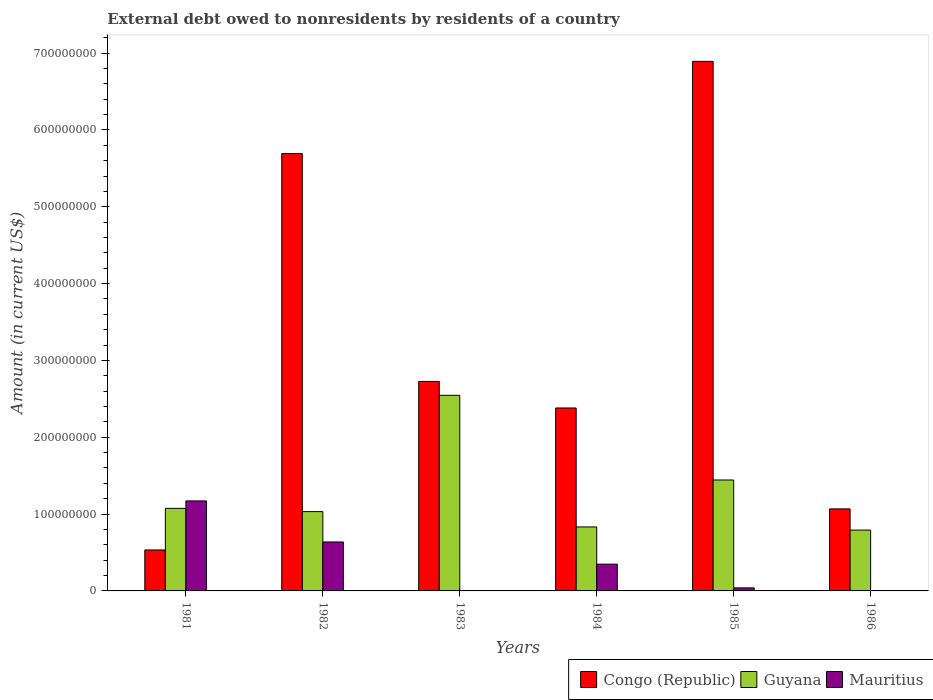How many different coloured bars are there?
Your answer should be compact. 3. How many bars are there on the 1st tick from the right?
Your answer should be very brief. 2. What is the label of the 1st group of bars from the left?
Your answer should be compact. 1981. In how many cases, is the number of bars for a given year not equal to the number of legend labels?
Provide a short and direct response. 2. Across all years, what is the maximum external debt owed by residents in Mauritius?
Your answer should be very brief. 1.17e+08. Across all years, what is the minimum external debt owed by residents in Congo (Republic)?
Your response must be concise. 5.33e+07. What is the total external debt owed by residents in Mauritius in the graph?
Your response must be concise. 2.20e+08. What is the difference between the external debt owed by residents in Congo (Republic) in 1982 and that in 1983?
Offer a very short reply. 2.97e+08. What is the difference between the external debt owed by residents in Mauritius in 1986 and the external debt owed by residents in Guyana in 1983?
Make the answer very short. -2.55e+08. What is the average external debt owed by residents in Guyana per year?
Give a very brief answer. 1.29e+08. In the year 1981, what is the difference between the external debt owed by residents in Congo (Republic) and external debt owed by residents in Mauritius?
Offer a terse response. -6.38e+07. In how many years, is the external debt owed by residents in Congo (Republic) greater than 40000000 US$?
Keep it short and to the point. 6. What is the ratio of the external debt owed by residents in Congo (Republic) in 1985 to that in 1986?
Keep it short and to the point. 6.46. Is the external debt owed by residents in Congo (Republic) in 1983 less than that in 1984?
Your answer should be compact. No. What is the difference between the highest and the second highest external debt owed by residents in Guyana?
Your answer should be compact. 1.10e+08. What is the difference between the highest and the lowest external debt owed by residents in Guyana?
Provide a short and direct response. 1.75e+08. In how many years, is the external debt owed by residents in Guyana greater than the average external debt owed by residents in Guyana taken over all years?
Provide a succinct answer. 2. Are all the bars in the graph horizontal?
Give a very brief answer. No. How many years are there in the graph?
Provide a short and direct response. 6. What is the difference between two consecutive major ticks on the Y-axis?
Provide a short and direct response. 1.00e+08. Does the graph contain grids?
Ensure brevity in your answer.  No. Where does the legend appear in the graph?
Make the answer very short. Bottom right. How many legend labels are there?
Your answer should be very brief. 3. How are the legend labels stacked?
Your response must be concise. Horizontal. What is the title of the graph?
Provide a short and direct response. External debt owed to nonresidents by residents of a country. What is the label or title of the X-axis?
Give a very brief answer. Years. What is the label or title of the Y-axis?
Your response must be concise. Amount (in current US$). What is the Amount (in current US$) of Congo (Republic) in 1981?
Your answer should be compact. 5.33e+07. What is the Amount (in current US$) in Guyana in 1981?
Keep it short and to the point. 1.07e+08. What is the Amount (in current US$) of Mauritius in 1981?
Give a very brief answer. 1.17e+08. What is the Amount (in current US$) of Congo (Republic) in 1982?
Ensure brevity in your answer.  5.69e+08. What is the Amount (in current US$) in Guyana in 1982?
Your answer should be compact. 1.03e+08. What is the Amount (in current US$) in Mauritius in 1982?
Provide a succinct answer. 6.37e+07. What is the Amount (in current US$) in Congo (Republic) in 1983?
Make the answer very short. 2.73e+08. What is the Amount (in current US$) of Guyana in 1983?
Offer a terse response. 2.55e+08. What is the Amount (in current US$) in Congo (Republic) in 1984?
Provide a succinct answer. 2.38e+08. What is the Amount (in current US$) of Guyana in 1984?
Give a very brief answer. 8.33e+07. What is the Amount (in current US$) in Mauritius in 1984?
Your answer should be compact. 3.48e+07. What is the Amount (in current US$) in Congo (Republic) in 1985?
Keep it short and to the point. 6.89e+08. What is the Amount (in current US$) of Guyana in 1985?
Offer a terse response. 1.44e+08. What is the Amount (in current US$) of Mauritius in 1985?
Keep it short and to the point. 3.95e+06. What is the Amount (in current US$) of Congo (Republic) in 1986?
Offer a terse response. 1.07e+08. What is the Amount (in current US$) in Guyana in 1986?
Provide a short and direct response. 7.92e+07. Across all years, what is the maximum Amount (in current US$) in Congo (Republic)?
Your answer should be very brief. 6.89e+08. Across all years, what is the maximum Amount (in current US$) of Guyana?
Provide a short and direct response. 2.55e+08. Across all years, what is the maximum Amount (in current US$) of Mauritius?
Make the answer very short. 1.17e+08. Across all years, what is the minimum Amount (in current US$) in Congo (Republic)?
Make the answer very short. 5.33e+07. Across all years, what is the minimum Amount (in current US$) of Guyana?
Make the answer very short. 7.92e+07. Across all years, what is the minimum Amount (in current US$) of Mauritius?
Give a very brief answer. 0. What is the total Amount (in current US$) of Congo (Republic) in the graph?
Ensure brevity in your answer.  1.93e+09. What is the total Amount (in current US$) in Guyana in the graph?
Keep it short and to the point. 7.72e+08. What is the total Amount (in current US$) of Mauritius in the graph?
Offer a very short reply. 2.20e+08. What is the difference between the Amount (in current US$) of Congo (Republic) in 1981 and that in 1982?
Your answer should be compact. -5.16e+08. What is the difference between the Amount (in current US$) in Guyana in 1981 and that in 1982?
Provide a short and direct response. 4.26e+06. What is the difference between the Amount (in current US$) in Mauritius in 1981 and that in 1982?
Make the answer very short. 5.34e+07. What is the difference between the Amount (in current US$) in Congo (Republic) in 1981 and that in 1983?
Your answer should be compact. -2.19e+08. What is the difference between the Amount (in current US$) of Guyana in 1981 and that in 1983?
Ensure brevity in your answer.  -1.47e+08. What is the difference between the Amount (in current US$) in Congo (Republic) in 1981 and that in 1984?
Your answer should be very brief. -1.85e+08. What is the difference between the Amount (in current US$) in Guyana in 1981 and that in 1984?
Provide a succinct answer. 2.42e+07. What is the difference between the Amount (in current US$) of Mauritius in 1981 and that in 1984?
Provide a short and direct response. 8.23e+07. What is the difference between the Amount (in current US$) of Congo (Republic) in 1981 and that in 1985?
Ensure brevity in your answer.  -6.36e+08. What is the difference between the Amount (in current US$) of Guyana in 1981 and that in 1985?
Your answer should be compact. -3.69e+07. What is the difference between the Amount (in current US$) of Mauritius in 1981 and that in 1985?
Your answer should be compact. 1.13e+08. What is the difference between the Amount (in current US$) in Congo (Republic) in 1981 and that in 1986?
Ensure brevity in your answer.  -5.35e+07. What is the difference between the Amount (in current US$) in Guyana in 1981 and that in 1986?
Ensure brevity in your answer.  2.83e+07. What is the difference between the Amount (in current US$) in Congo (Republic) in 1982 and that in 1983?
Make the answer very short. 2.97e+08. What is the difference between the Amount (in current US$) of Guyana in 1982 and that in 1983?
Your response must be concise. -1.51e+08. What is the difference between the Amount (in current US$) of Congo (Republic) in 1982 and that in 1984?
Ensure brevity in your answer.  3.31e+08. What is the difference between the Amount (in current US$) in Guyana in 1982 and that in 1984?
Keep it short and to the point. 1.99e+07. What is the difference between the Amount (in current US$) of Mauritius in 1982 and that in 1984?
Offer a very short reply. 2.89e+07. What is the difference between the Amount (in current US$) in Congo (Republic) in 1982 and that in 1985?
Your answer should be very brief. -1.20e+08. What is the difference between the Amount (in current US$) of Guyana in 1982 and that in 1985?
Ensure brevity in your answer.  -4.12e+07. What is the difference between the Amount (in current US$) of Mauritius in 1982 and that in 1985?
Offer a terse response. 5.98e+07. What is the difference between the Amount (in current US$) in Congo (Republic) in 1982 and that in 1986?
Offer a terse response. 4.62e+08. What is the difference between the Amount (in current US$) in Guyana in 1982 and that in 1986?
Keep it short and to the point. 2.40e+07. What is the difference between the Amount (in current US$) of Congo (Republic) in 1983 and that in 1984?
Your answer should be compact. 3.45e+07. What is the difference between the Amount (in current US$) of Guyana in 1983 and that in 1984?
Your answer should be compact. 1.71e+08. What is the difference between the Amount (in current US$) of Congo (Republic) in 1983 and that in 1985?
Make the answer very short. -4.17e+08. What is the difference between the Amount (in current US$) of Guyana in 1983 and that in 1985?
Provide a succinct answer. 1.10e+08. What is the difference between the Amount (in current US$) in Congo (Republic) in 1983 and that in 1986?
Your answer should be very brief. 1.66e+08. What is the difference between the Amount (in current US$) of Guyana in 1983 and that in 1986?
Give a very brief answer. 1.75e+08. What is the difference between the Amount (in current US$) of Congo (Republic) in 1984 and that in 1985?
Keep it short and to the point. -4.51e+08. What is the difference between the Amount (in current US$) of Guyana in 1984 and that in 1985?
Offer a very short reply. -6.11e+07. What is the difference between the Amount (in current US$) of Mauritius in 1984 and that in 1985?
Your answer should be compact. 3.09e+07. What is the difference between the Amount (in current US$) in Congo (Republic) in 1984 and that in 1986?
Your answer should be compact. 1.31e+08. What is the difference between the Amount (in current US$) of Guyana in 1984 and that in 1986?
Offer a terse response. 4.12e+06. What is the difference between the Amount (in current US$) of Congo (Republic) in 1985 and that in 1986?
Provide a succinct answer. 5.83e+08. What is the difference between the Amount (in current US$) in Guyana in 1985 and that in 1986?
Provide a short and direct response. 6.52e+07. What is the difference between the Amount (in current US$) in Congo (Republic) in 1981 and the Amount (in current US$) in Guyana in 1982?
Make the answer very short. -4.99e+07. What is the difference between the Amount (in current US$) in Congo (Republic) in 1981 and the Amount (in current US$) in Mauritius in 1982?
Ensure brevity in your answer.  -1.04e+07. What is the difference between the Amount (in current US$) of Guyana in 1981 and the Amount (in current US$) of Mauritius in 1982?
Offer a very short reply. 4.38e+07. What is the difference between the Amount (in current US$) in Congo (Republic) in 1981 and the Amount (in current US$) in Guyana in 1983?
Make the answer very short. -2.01e+08. What is the difference between the Amount (in current US$) in Congo (Republic) in 1981 and the Amount (in current US$) in Guyana in 1984?
Make the answer very short. -3.00e+07. What is the difference between the Amount (in current US$) of Congo (Republic) in 1981 and the Amount (in current US$) of Mauritius in 1984?
Your response must be concise. 1.85e+07. What is the difference between the Amount (in current US$) of Guyana in 1981 and the Amount (in current US$) of Mauritius in 1984?
Provide a succinct answer. 7.26e+07. What is the difference between the Amount (in current US$) of Congo (Republic) in 1981 and the Amount (in current US$) of Guyana in 1985?
Provide a short and direct response. -9.11e+07. What is the difference between the Amount (in current US$) of Congo (Republic) in 1981 and the Amount (in current US$) of Mauritius in 1985?
Offer a terse response. 4.94e+07. What is the difference between the Amount (in current US$) in Guyana in 1981 and the Amount (in current US$) in Mauritius in 1985?
Keep it short and to the point. 1.04e+08. What is the difference between the Amount (in current US$) in Congo (Republic) in 1981 and the Amount (in current US$) in Guyana in 1986?
Provide a succinct answer. -2.59e+07. What is the difference between the Amount (in current US$) of Congo (Republic) in 1982 and the Amount (in current US$) of Guyana in 1983?
Ensure brevity in your answer.  3.15e+08. What is the difference between the Amount (in current US$) in Congo (Republic) in 1982 and the Amount (in current US$) in Guyana in 1984?
Provide a short and direct response. 4.86e+08. What is the difference between the Amount (in current US$) of Congo (Republic) in 1982 and the Amount (in current US$) of Mauritius in 1984?
Keep it short and to the point. 5.34e+08. What is the difference between the Amount (in current US$) in Guyana in 1982 and the Amount (in current US$) in Mauritius in 1984?
Ensure brevity in your answer.  6.84e+07. What is the difference between the Amount (in current US$) of Congo (Republic) in 1982 and the Amount (in current US$) of Guyana in 1985?
Offer a very short reply. 4.25e+08. What is the difference between the Amount (in current US$) of Congo (Republic) in 1982 and the Amount (in current US$) of Mauritius in 1985?
Your answer should be very brief. 5.65e+08. What is the difference between the Amount (in current US$) in Guyana in 1982 and the Amount (in current US$) in Mauritius in 1985?
Your answer should be very brief. 9.93e+07. What is the difference between the Amount (in current US$) of Congo (Republic) in 1982 and the Amount (in current US$) of Guyana in 1986?
Provide a short and direct response. 4.90e+08. What is the difference between the Amount (in current US$) of Congo (Republic) in 1983 and the Amount (in current US$) of Guyana in 1984?
Your response must be concise. 1.89e+08. What is the difference between the Amount (in current US$) in Congo (Republic) in 1983 and the Amount (in current US$) in Mauritius in 1984?
Ensure brevity in your answer.  2.38e+08. What is the difference between the Amount (in current US$) in Guyana in 1983 and the Amount (in current US$) in Mauritius in 1984?
Offer a terse response. 2.20e+08. What is the difference between the Amount (in current US$) of Congo (Republic) in 1983 and the Amount (in current US$) of Guyana in 1985?
Provide a succinct answer. 1.28e+08. What is the difference between the Amount (in current US$) in Congo (Republic) in 1983 and the Amount (in current US$) in Mauritius in 1985?
Give a very brief answer. 2.69e+08. What is the difference between the Amount (in current US$) of Guyana in 1983 and the Amount (in current US$) of Mauritius in 1985?
Your answer should be compact. 2.51e+08. What is the difference between the Amount (in current US$) of Congo (Republic) in 1983 and the Amount (in current US$) of Guyana in 1986?
Offer a terse response. 1.93e+08. What is the difference between the Amount (in current US$) in Congo (Republic) in 1984 and the Amount (in current US$) in Guyana in 1985?
Your answer should be very brief. 9.37e+07. What is the difference between the Amount (in current US$) in Congo (Republic) in 1984 and the Amount (in current US$) in Mauritius in 1985?
Ensure brevity in your answer.  2.34e+08. What is the difference between the Amount (in current US$) of Guyana in 1984 and the Amount (in current US$) of Mauritius in 1985?
Give a very brief answer. 7.93e+07. What is the difference between the Amount (in current US$) in Congo (Republic) in 1984 and the Amount (in current US$) in Guyana in 1986?
Offer a very short reply. 1.59e+08. What is the difference between the Amount (in current US$) of Congo (Republic) in 1985 and the Amount (in current US$) of Guyana in 1986?
Your answer should be compact. 6.10e+08. What is the average Amount (in current US$) of Congo (Republic) per year?
Give a very brief answer. 3.22e+08. What is the average Amount (in current US$) of Guyana per year?
Make the answer very short. 1.29e+08. What is the average Amount (in current US$) in Mauritius per year?
Offer a terse response. 3.66e+07. In the year 1981, what is the difference between the Amount (in current US$) of Congo (Republic) and Amount (in current US$) of Guyana?
Keep it short and to the point. -5.42e+07. In the year 1981, what is the difference between the Amount (in current US$) in Congo (Republic) and Amount (in current US$) in Mauritius?
Your answer should be compact. -6.38e+07. In the year 1981, what is the difference between the Amount (in current US$) of Guyana and Amount (in current US$) of Mauritius?
Give a very brief answer. -9.66e+06. In the year 1982, what is the difference between the Amount (in current US$) of Congo (Republic) and Amount (in current US$) of Guyana?
Your answer should be compact. 4.66e+08. In the year 1982, what is the difference between the Amount (in current US$) in Congo (Republic) and Amount (in current US$) in Mauritius?
Your answer should be compact. 5.05e+08. In the year 1982, what is the difference between the Amount (in current US$) of Guyana and Amount (in current US$) of Mauritius?
Provide a succinct answer. 3.95e+07. In the year 1983, what is the difference between the Amount (in current US$) in Congo (Republic) and Amount (in current US$) in Guyana?
Make the answer very short. 1.80e+07. In the year 1984, what is the difference between the Amount (in current US$) of Congo (Republic) and Amount (in current US$) of Guyana?
Provide a short and direct response. 1.55e+08. In the year 1984, what is the difference between the Amount (in current US$) of Congo (Republic) and Amount (in current US$) of Mauritius?
Offer a very short reply. 2.03e+08. In the year 1984, what is the difference between the Amount (in current US$) of Guyana and Amount (in current US$) of Mauritius?
Your response must be concise. 4.85e+07. In the year 1985, what is the difference between the Amount (in current US$) of Congo (Republic) and Amount (in current US$) of Guyana?
Ensure brevity in your answer.  5.45e+08. In the year 1985, what is the difference between the Amount (in current US$) of Congo (Republic) and Amount (in current US$) of Mauritius?
Your answer should be compact. 6.85e+08. In the year 1985, what is the difference between the Amount (in current US$) of Guyana and Amount (in current US$) of Mauritius?
Give a very brief answer. 1.40e+08. In the year 1986, what is the difference between the Amount (in current US$) of Congo (Republic) and Amount (in current US$) of Guyana?
Keep it short and to the point. 2.76e+07. What is the ratio of the Amount (in current US$) of Congo (Republic) in 1981 to that in 1982?
Make the answer very short. 0.09. What is the ratio of the Amount (in current US$) in Guyana in 1981 to that in 1982?
Provide a short and direct response. 1.04. What is the ratio of the Amount (in current US$) of Mauritius in 1981 to that in 1982?
Give a very brief answer. 1.84. What is the ratio of the Amount (in current US$) of Congo (Republic) in 1981 to that in 1983?
Provide a short and direct response. 0.2. What is the ratio of the Amount (in current US$) in Guyana in 1981 to that in 1983?
Ensure brevity in your answer.  0.42. What is the ratio of the Amount (in current US$) of Congo (Republic) in 1981 to that in 1984?
Keep it short and to the point. 0.22. What is the ratio of the Amount (in current US$) of Guyana in 1981 to that in 1984?
Your answer should be very brief. 1.29. What is the ratio of the Amount (in current US$) in Mauritius in 1981 to that in 1984?
Your answer should be compact. 3.36. What is the ratio of the Amount (in current US$) of Congo (Republic) in 1981 to that in 1985?
Offer a very short reply. 0.08. What is the ratio of the Amount (in current US$) in Guyana in 1981 to that in 1985?
Your answer should be very brief. 0.74. What is the ratio of the Amount (in current US$) in Mauritius in 1981 to that in 1985?
Ensure brevity in your answer.  29.63. What is the ratio of the Amount (in current US$) of Congo (Republic) in 1981 to that in 1986?
Make the answer very short. 0.5. What is the ratio of the Amount (in current US$) of Guyana in 1981 to that in 1986?
Offer a very short reply. 1.36. What is the ratio of the Amount (in current US$) of Congo (Republic) in 1982 to that in 1983?
Your response must be concise. 2.09. What is the ratio of the Amount (in current US$) of Guyana in 1982 to that in 1983?
Make the answer very short. 0.41. What is the ratio of the Amount (in current US$) in Congo (Republic) in 1982 to that in 1984?
Give a very brief answer. 2.39. What is the ratio of the Amount (in current US$) in Guyana in 1982 to that in 1984?
Make the answer very short. 1.24. What is the ratio of the Amount (in current US$) of Mauritius in 1982 to that in 1984?
Your answer should be compact. 1.83. What is the ratio of the Amount (in current US$) in Congo (Republic) in 1982 to that in 1985?
Give a very brief answer. 0.83. What is the ratio of the Amount (in current US$) of Guyana in 1982 to that in 1985?
Make the answer very short. 0.71. What is the ratio of the Amount (in current US$) in Mauritius in 1982 to that in 1985?
Keep it short and to the point. 16.11. What is the ratio of the Amount (in current US$) of Congo (Republic) in 1982 to that in 1986?
Keep it short and to the point. 5.33. What is the ratio of the Amount (in current US$) of Guyana in 1982 to that in 1986?
Offer a terse response. 1.3. What is the ratio of the Amount (in current US$) of Congo (Republic) in 1983 to that in 1984?
Make the answer very short. 1.15. What is the ratio of the Amount (in current US$) in Guyana in 1983 to that in 1984?
Your answer should be compact. 3.06. What is the ratio of the Amount (in current US$) in Congo (Republic) in 1983 to that in 1985?
Ensure brevity in your answer.  0.4. What is the ratio of the Amount (in current US$) in Guyana in 1983 to that in 1985?
Provide a succinct answer. 1.76. What is the ratio of the Amount (in current US$) of Congo (Republic) in 1983 to that in 1986?
Ensure brevity in your answer.  2.55. What is the ratio of the Amount (in current US$) in Guyana in 1983 to that in 1986?
Provide a short and direct response. 3.22. What is the ratio of the Amount (in current US$) in Congo (Republic) in 1984 to that in 1985?
Keep it short and to the point. 0.35. What is the ratio of the Amount (in current US$) in Guyana in 1984 to that in 1985?
Your answer should be compact. 0.58. What is the ratio of the Amount (in current US$) in Mauritius in 1984 to that in 1985?
Provide a short and direct response. 8.81. What is the ratio of the Amount (in current US$) in Congo (Republic) in 1984 to that in 1986?
Make the answer very short. 2.23. What is the ratio of the Amount (in current US$) in Guyana in 1984 to that in 1986?
Give a very brief answer. 1.05. What is the ratio of the Amount (in current US$) of Congo (Republic) in 1985 to that in 1986?
Your answer should be compact. 6.46. What is the ratio of the Amount (in current US$) of Guyana in 1985 to that in 1986?
Offer a very short reply. 1.82. What is the difference between the highest and the second highest Amount (in current US$) in Congo (Republic)?
Your response must be concise. 1.20e+08. What is the difference between the highest and the second highest Amount (in current US$) of Guyana?
Offer a very short reply. 1.10e+08. What is the difference between the highest and the second highest Amount (in current US$) in Mauritius?
Offer a terse response. 5.34e+07. What is the difference between the highest and the lowest Amount (in current US$) of Congo (Republic)?
Offer a very short reply. 6.36e+08. What is the difference between the highest and the lowest Amount (in current US$) in Guyana?
Keep it short and to the point. 1.75e+08. What is the difference between the highest and the lowest Amount (in current US$) of Mauritius?
Your answer should be compact. 1.17e+08. 